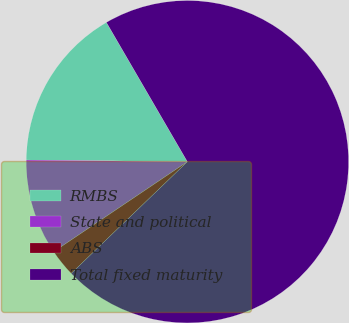<chart> <loc_0><loc_0><loc_500><loc_500><pie_chart><fcel>RMBS<fcel>State and political<fcel>ABS<fcel>Total fixed maturity<nl><fcel>16.45%<fcel>9.6%<fcel>2.76%<fcel>71.19%<nl></chart> 